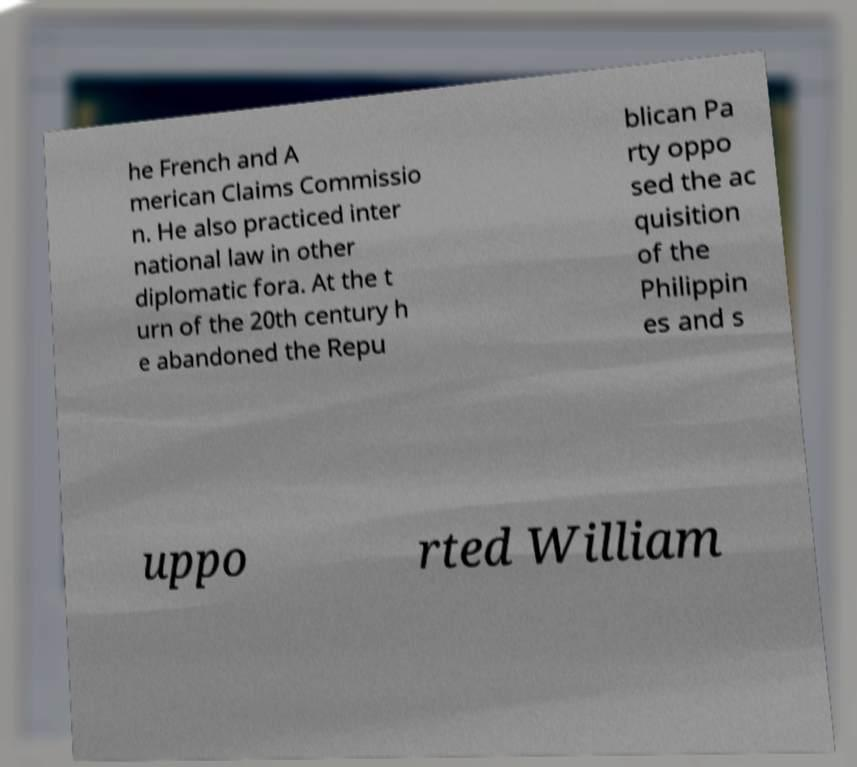For documentation purposes, I need the text within this image transcribed. Could you provide that? he French and A merican Claims Commissio n. He also practiced inter national law in other diplomatic fora. At the t urn of the 20th century h e abandoned the Repu blican Pa rty oppo sed the ac quisition of the Philippin es and s uppo rted William 